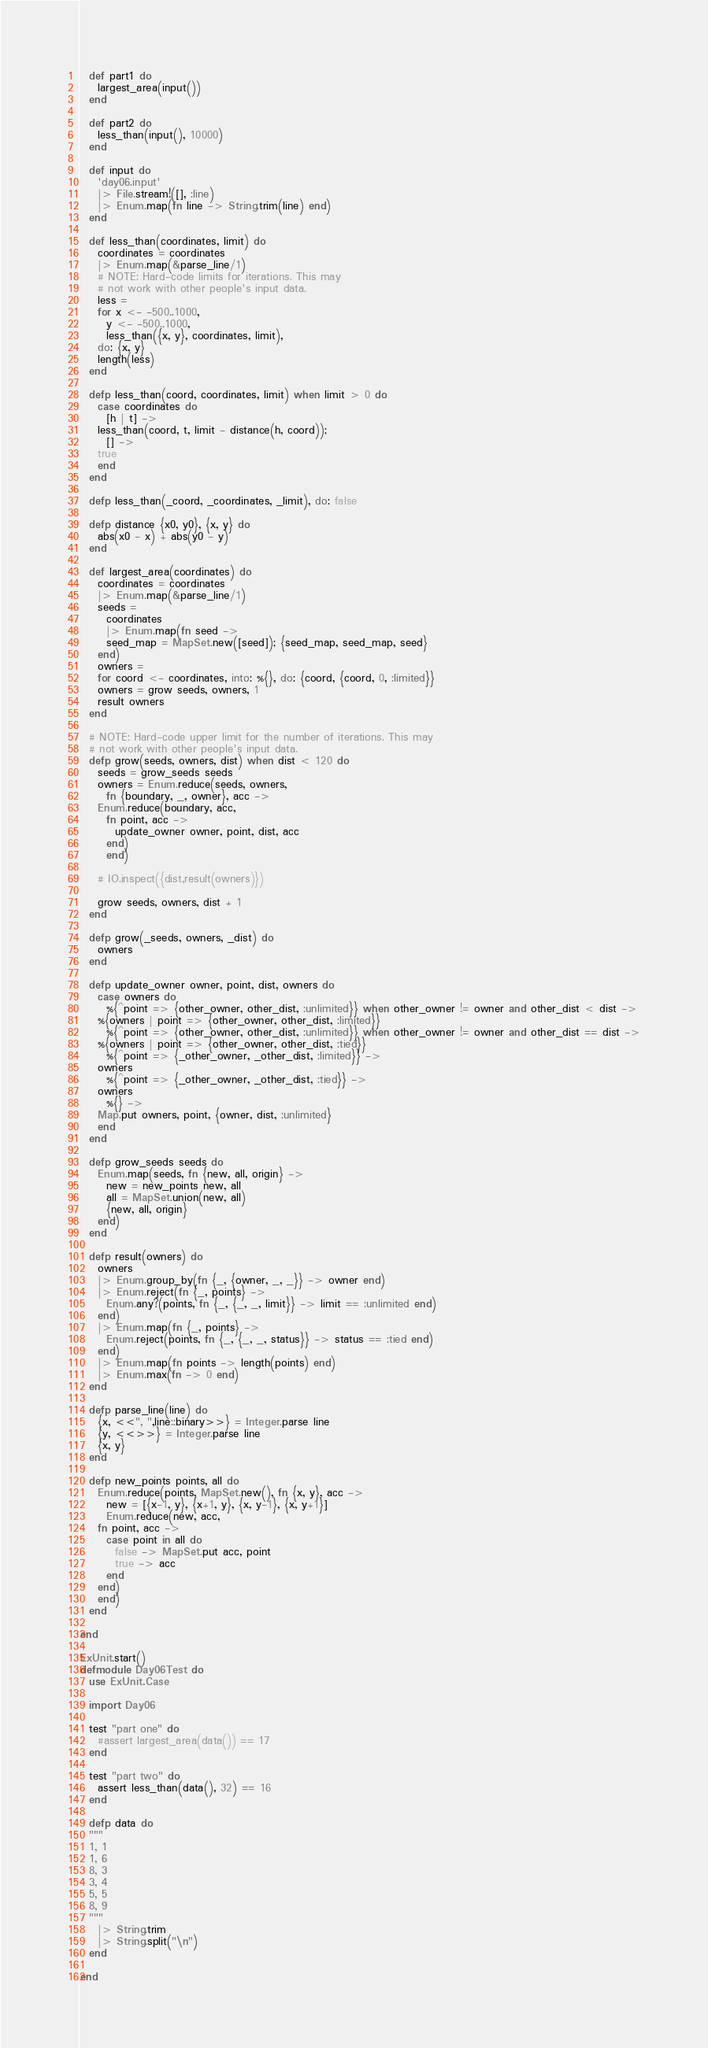<code> <loc_0><loc_0><loc_500><loc_500><_Elixir_>  def part1 do
    largest_area(input())
  end

  def part2 do
    less_than(input(), 10000)
  end

  def input do
    'day06.input'
    |> File.stream!([], :line)
    |> Enum.map(fn line -> String.trim(line) end)
  end

  def less_than(coordinates, limit) do
    coordinates = coordinates
    |> Enum.map(&parse_line/1)
    # NOTE: Hard-code limits for iterations. This may
    # not work with other people's input data.
    less =
    for x <- -500..1000,
      y <- -500..1000,
      less_than({x, y}, coordinates, limit),
	do: {x, y}
	length(less)
  end

  defp less_than(coord, coordinates, limit) when limit > 0 do
    case coordinates do
      [h | t] ->
	less_than(coord, t, limit - distance(h, coord));
      [] ->
	true
    end
  end

  defp less_than(_coord, _coordinates, _limit), do: false

  defp distance {x0, y0}, {x, y} do
    abs(x0 - x) + abs(y0 - y)
  end

  def largest_area(coordinates) do
    coordinates = coordinates
    |> Enum.map(&parse_line/1)
    seeds =
      coordinates
      |> Enum.map(fn seed ->
      seed_map = MapSet.new([seed]); {seed_map, seed_map, seed}
    end)
    owners =
    for coord <- coordinates, into: %{}, do: {coord, {coord, 0, :limited}}
    owners = grow seeds, owners, 1
    result owners
  end

  # NOTE: Hard-code upper limit for the number of iterations. This may
  # not work with other people's input data.
  defp grow(seeds, owners, dist) when dist < 120 do
    seeds = grow_seeds seeds
    owners = Enum.reduce(seeds, owners,
      fn {boundary, _, owner}, acc ->
	Enum.reduce(boundary, acc,
	  fn point, acc ->
	    update_owner owner, point, dist, acc
	  end)
      end)

    # IO.inspect({dist,result(owners)})

    grow seeds, owners, dist + 1
  end

  defp grow(_seeds, owners, _dist) do
    owners
  end

  defp update_owner owner, point, dist, owners do
    case owners do
      %{^point => {other_owner, other_dist, :unlimited}} when other_owner != owner and other_dist < dist ->
	%{owners | point => {other_owner, other_dist, :limited}}
      %{^point => {other_owner, other_dist, :unlimited}} when other_owner != owner and other_dist == dist ->
	%{owners | point => {other_owner, other_dist, :tied}}
      %{^point => {_other_owner, _other_dist, :limited}} ->
	owners
      %{^point => {_other_owner, _other_dist, :tied}} ->
	owners
      %{} ->
	Map.put owners, point, {owner, dist, :unlimited}
    end
  end

  defp grow_seeds seeds do
    Enum.map(seeds, fn {new, all, origin} ->
      new = new_points new, all
      all = MapSet.union(new, all)
      {new, all, origin}
    end)
  end

  defp result(owners) do
    owners
    |> Enum.group_by(fn {_, {owner, _, _}} -> owner end)
    |> Enum.reject(fn {_, points} ->
      Enum.any?(points, fn {_, {_, _, limit}} -> limit == :unlimited end)
    end)
    |> Enum.map(fn {_, points} ->
      Enum.reject(points, fn {_, {_, _, status}} -> status == :tied end)
    end)
    |> Enum.map(fn points -> length(points) end)
    |> Enum.max(fn -> 0 end)
  end

  defp parse_line(line) do
    {x, <<", ",line::binary>>} = Integer.parse line
    {y, <<>>} = Integer.parse line
    {x, y}
  end

  defp new_points points, all do
    Enum.reduce(points, MapSet.new(), fn {x, y}, acc ->
      new = [{x-1, y}, {x+1, y}, {x, y-1}, {x, y+1}]
      Enum.reduce(new, acc,
	fn point, acc ->
	  case point in all do
	    false -> MapSet.put acc, point
	    true -> acc
	  end
	end)
    end)
  end

end

ExUnit.start()
defmodule Day06Test do
  use ExUnit.Case

  import Day06

  test "part one" do
    #assert largest_area(data()) == 17
  end

  test "part two" do
    assert less_than(data(), 32) == 16
  end

  defp data do
  """
  1, 1
  1, 6
  8, 3
  3, 4
  5, 5
  8, 9
  """
    |> String.trim
    |> String.split("\n")
  end

end
</code> 